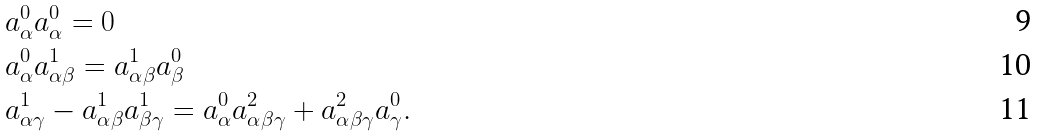<formula> <loc_0><loc_0><loc_500><loc_500>& a _ { \alpha } ^ { 0 } a _ { \alpha } ^ { 0 } = 0 \\ & a _ { \alpha } ^ { 0 } a _ { \alpha \beta } ^ { 1 } = a _ { \alpha \beta } ^ { 1 } a _ { \beta } ^ { 0 } \\ & a _ { \alpha \gamma } ^ { 1 } - a _ { \alpha \beta } ^ { 1 } a _ { \beta \gamma } ^ { 1 } = a _ { \alpha } ^ { 0 } a _ { \alpha \beta \gamma } ^ { 2 } + a _ { \alpha \beta \gamma } ^ { 2 } a _ { \gamma } ^ { 0 } .</formula> 